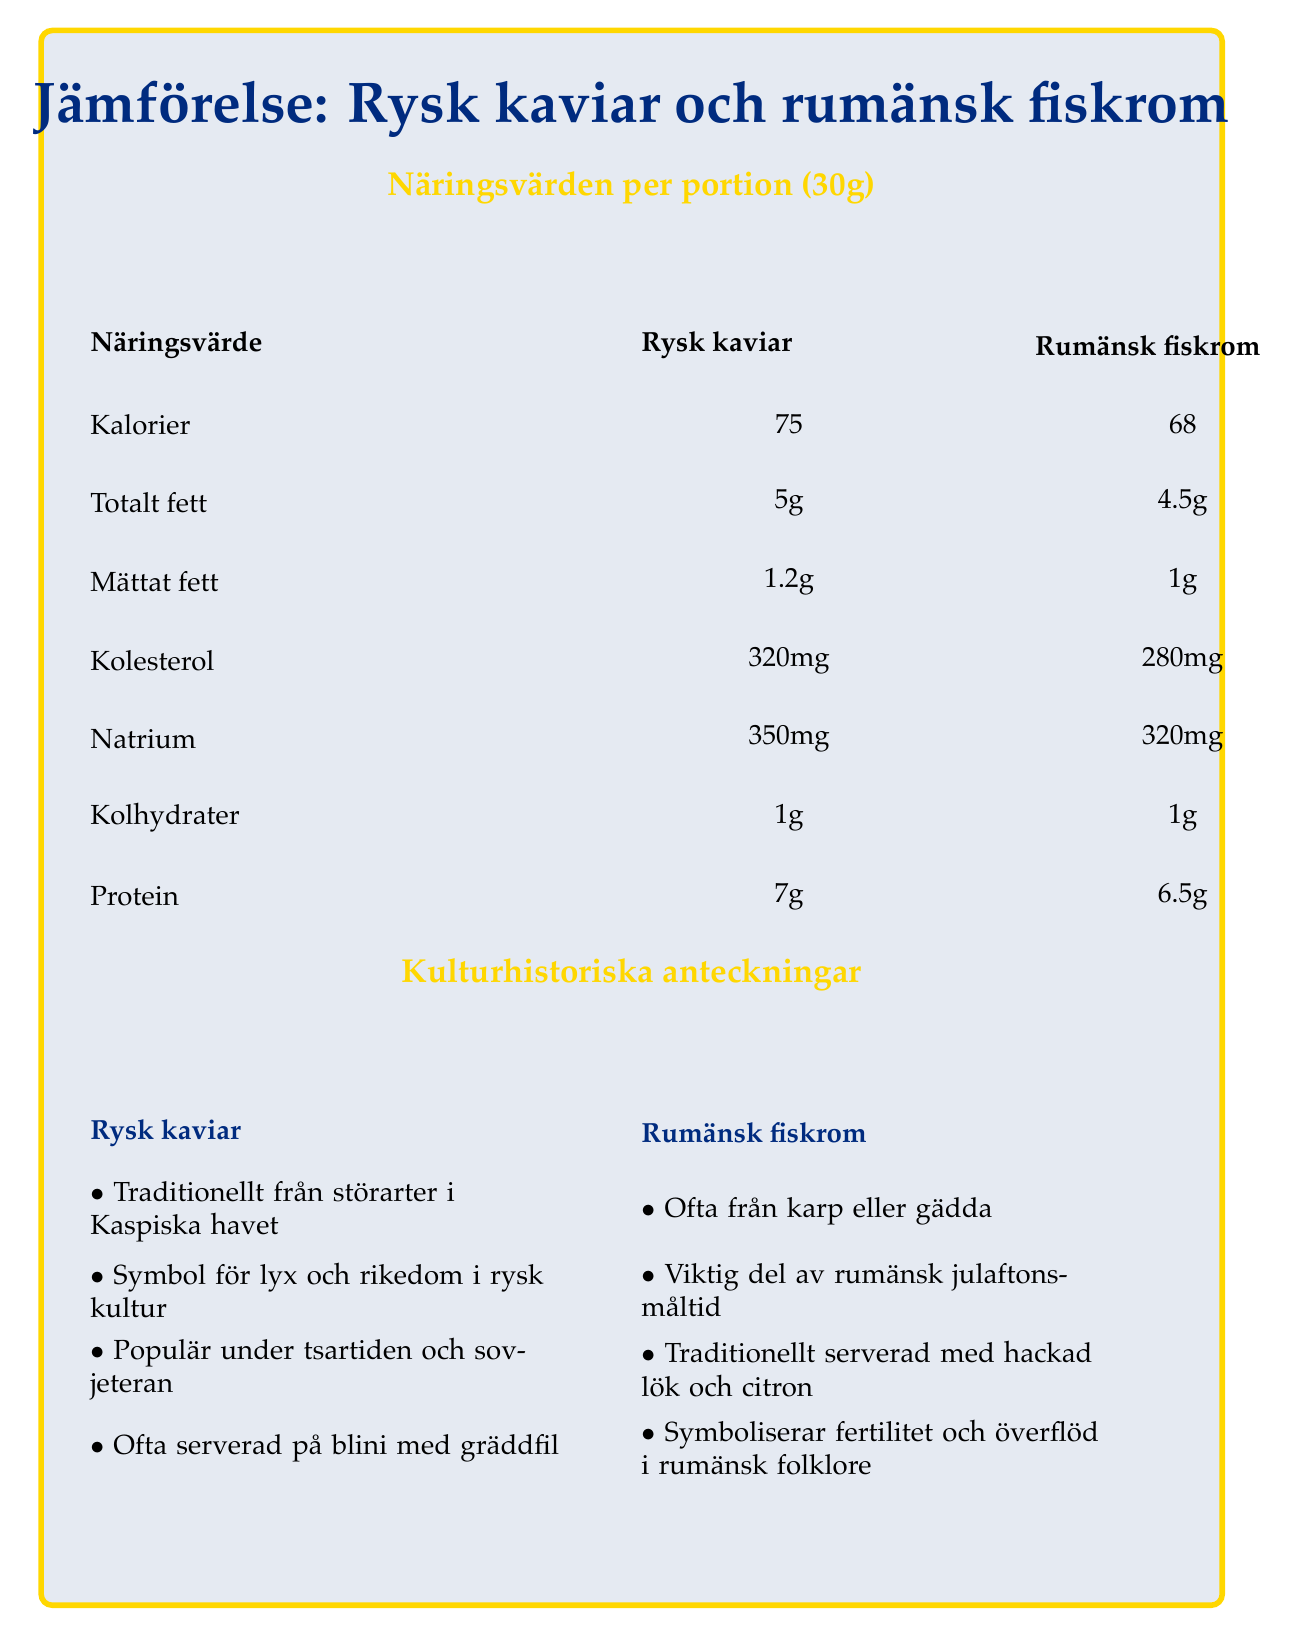What is the serving size mentioned for both products? The document states that the serving size for both Rysk kaviar and Rumänsk fiskrom is 30g.
Answer: 30g How many servings are there per container? The document specifies that there are 4 servings per container for both Rysk kaviar and Rumänsk fiskrom.
Answer: 4 What is the total fat content in Rysk kaviar per serving? According to the document, the total fat content in Rysk kaviar per serving is 5g.
Answer: 5g Which product has a higher protein content per serving? Rysk kaviar has 7g of protein per serving, compared to Rumänsk fiskrom, which has 6.5g.
Answer: Rysk kaviar What is the cholesterol content in Rumänsk fiskrom? The document indicates that Rumänsk fiskrom has a cholesterol content of 280mg per serving.
Answer: 280mg Which product has a higher sodium content? A. Rysk kaviar B. Rumänsk fiskrom C. Both have the same sodium content The document shows that Rysk kaviar has 350mg of sodium, while Rumänsk fiskrom has 320mg of sodium. Thus, Rysk kaviar has a higher sodium content.
Answer: A. Rysk kaviar In which historical era was Rysk kaviar popularized? I. Tsartiden II. Industrial revolution III. Soviet era IV. 1990s The document mentions that Rysk kaviar was popular during the Tsar period and the Soviet era.
Answer: I and III Which statement is true about the traditional preparation of Rumänsk fiskrom? A. Saltad och pastöriserad B. Sockerlagens med socker C. Saltad och torkad According to the document, Rumänsk fiskrom is often salted and dried.
Answer: C. Saltad och torkad Is it true that Rysk kaviar is often served on blini with sour cream? The document notes that Rysk kaviar is often served on blini (small pancakes) with sour cream.
Answer: Yes Summarize the main idea of the document. The document provides a comparative analysis of the nutritional content, cultural significance, historical context, and traditional preparation methods of Rysk kaviar and Rumänsk fiskrom.
Answer: The document compares the nutritional values between Rysk kaviar and Rumänsk fiskrom, providing information on calories, fat, cholesterol, sodium, carbohydrates, and protein per serving. It also includes cultural and historical notes on both products and their traditional preparation methods. What is the specific fish species used for Rysk kaviar? The document mentions that Rysk kaviar traditionally comes from sturgeon species in the Caspian Sea but does not specify a single fish species.
Answer: Cannot be determined 